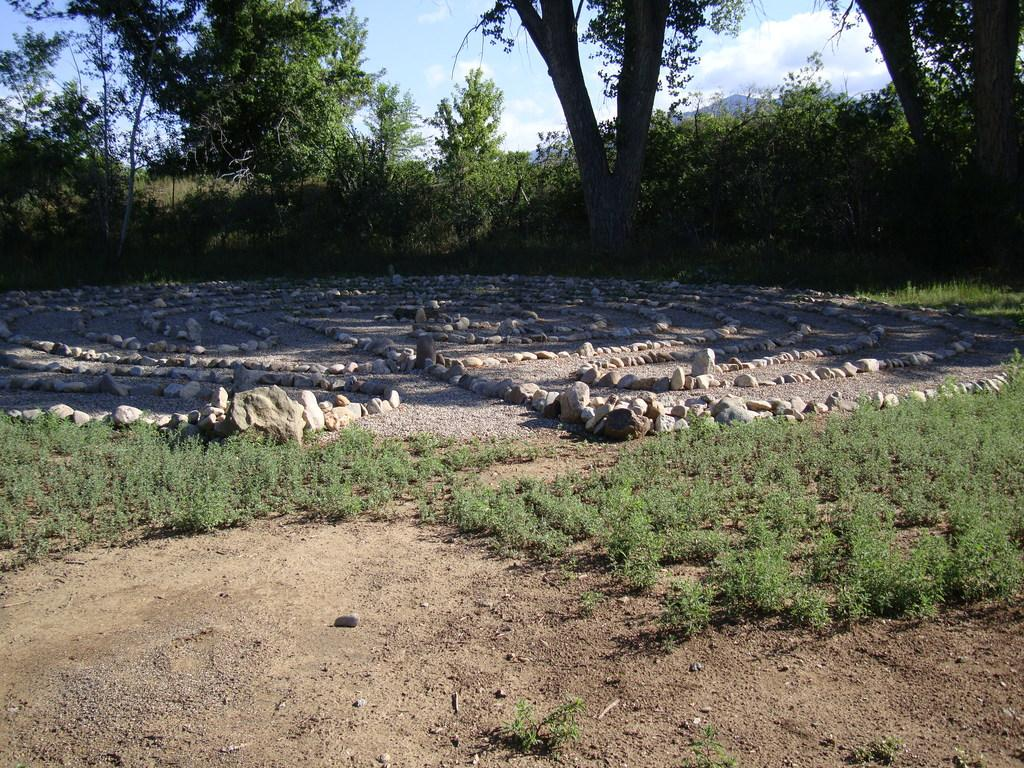What is the setting of the image? The image has an outside view. What can be seen in the foreground of the image? There are plants and stones in the foreground. What is visible in the background of the image? There are trees and the sky in the background. What flavor of straw is depicted in the image? There is no straw present in the image, so it is not possible to determine the flavor. 